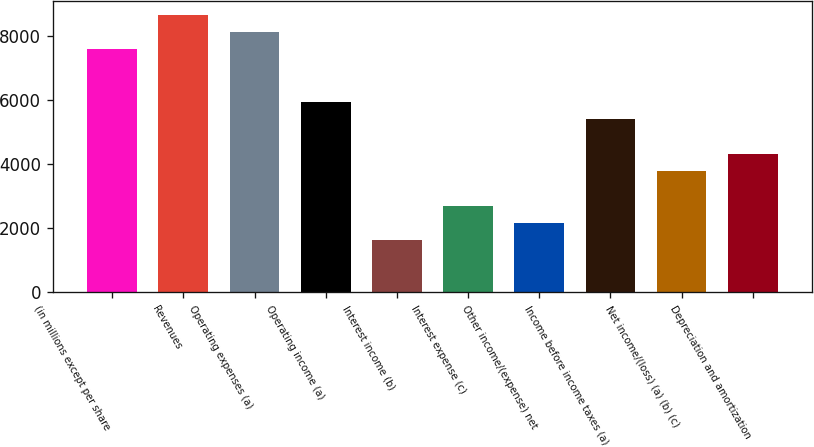<chart> <loc_0><loc_0><loc_500><loc_500><bar_chart><fcel>(in millions except per share<fcel>Revenues<fcel>Operating expenses (a)<fcel>Operating income (a)<fcel>Interest income (b)<fcel>Interest expense (c)<fcel>Other income/(expense) net<fcel>Income before income taxes (a)<fcel>Net income/(loss) (a) (b) (c)<fcel>Depreciation and amortization<nl><fcel>7591.87<fcel>8676.35<fcel>8134.11<fcel>5965.15<fcel>1627.23<fcel>2711.71<fcel>2169.47<fcel>5422.91<fcel>3796.19<fcel>4338.43<nl></chart> 